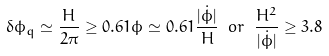<formula> <loc_0><loc_0><loc_500><loc_500>\delta \phi _ { q } \simeq \frac { H } { 2 \pi } \geq 0 . 6 1 \phi \simeq 0 . 6 1 \frac { | \dot { \phi } | } { H } \ o r \ \frac { H ^ { 2 } } { | \dot { \phi } | } \geq 3 . 8</formula> 